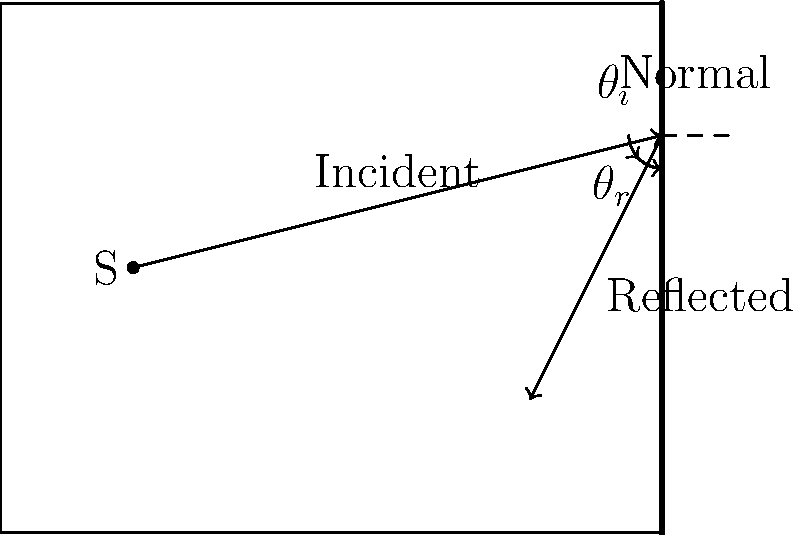In your recording studio, a sound wave from a source S is reflected off a wall as shown in the diagram. If the angle of incidence ($\theta_i$) is 45°, what is the angle of reflection ($\theta_r$)? How might this reflection affect the sound quality during a metal album recording session? To answer this question, let's follow these steps:

1. Recall the Law of Reflection: The angle of incidence ($\theta_i$) is equal to the angle of reflection ($\theta_r$).

2. Given information:
   - Angle of incidence ($\theta_i$) = 45°

3. Apply the Law of Reflection:
   $\theta_r = \theta_i = 45°$

4. Effect on sound quality:
   - Reflection creates reverb and echo effects, which can add depth and atmosphere to metal recordings.
   - However, excessive reflections can muddy the sound and reduce clarity, especially for fast, complex metal arrangements.
   - The 45° reflection angle might create standing waves at certain frequencies, potentially causing acoustic problems like room modes.
   - This could affect the accurate reproduction of bass frequencies, which are crucial for metal music.

5. Studio implications:
   - Proper acoustic treatment (e.g., diffusers, absorbers) might be necessary to control reflections.
   - The placement of instruments and microphones should consider these reflection patterns to capture the desired sound.
   - For reissuing classic metal albums, understanding these reflections can help in recreating the original recording environment or improving upon it.
Answer: 45°; can add depth but may require acoustic treatment to prevent muddiness and standing waves. 